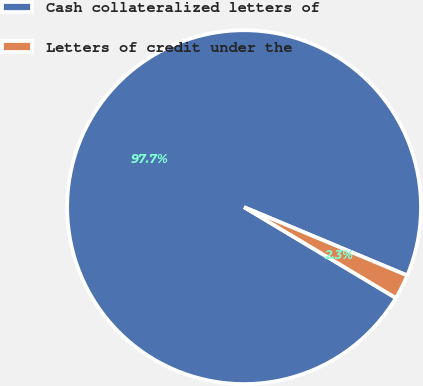Convert chart. <chart><loc_0><loc_0><loc_500><loc_500><pie_chart><fcel>Cash collateralized letters of<fcel>Letters of credit under the<nl><fcel>97.73%<fcel>2.27%<nl></chart> 